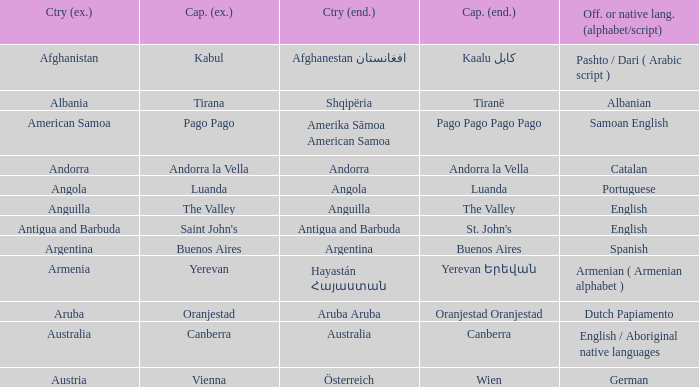What is the local name given to the capital of Anguilla? The Valley. 